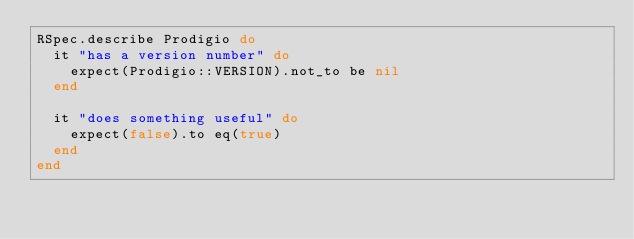Convert code to text. <code><loc_0><loc_0><loc_500><loc_500><_Ruby_>RSpec.describe Prodigio do
  it "has a version number" do
    expect(Prodigio::VERSION).not_to be nil
  end

  it "does something useful" do
    expect(false).to eq(true)
  end
end
</code> 